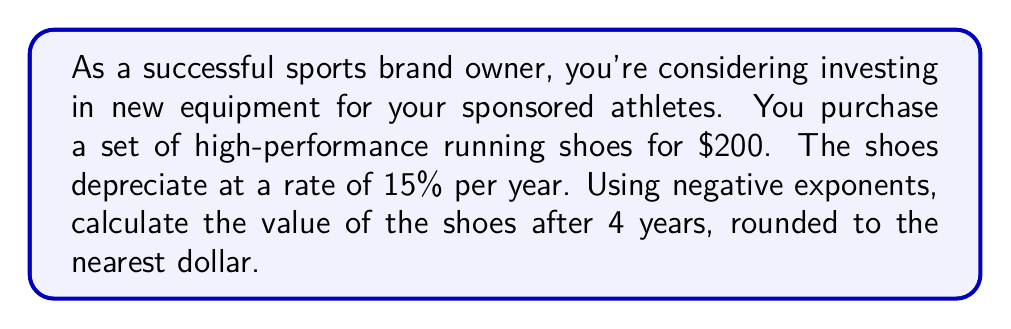Give your solution to this math problem. To solve this problem, we'll use the depreciation formula with negative exponents:

$$V = P(1-r)^{-n}$$

Where:
$V$ = Final value
$P$ = Initial price
$r$ = Depreciation rate (as a decimal)
$n$ = Number of years (negative exponent)

Given:
$P = \$200$
$r = 15\% = 0.15$
$n = 4$

Step 1: Plug the values into the formula
$$V = 200(1-0.15)^{-4}$$

Step 2: Simplify inside the parentheses
$$V = 200(0.85)^{-4}$$

Step 3: Calculate the exponent
$$V = 200 \cdot \frac{1}{(0.85)^4}$$

Step 4: Calculate the denominator
$$(0.85)^4 = 0.5220$$

Step 5: Divide
$$V = 200 \cdot \frac{1}{0.5220} = 383.14$$

Step 6: Round to the nearest dollar
$$V \approx \$383$$
Answer: $383 